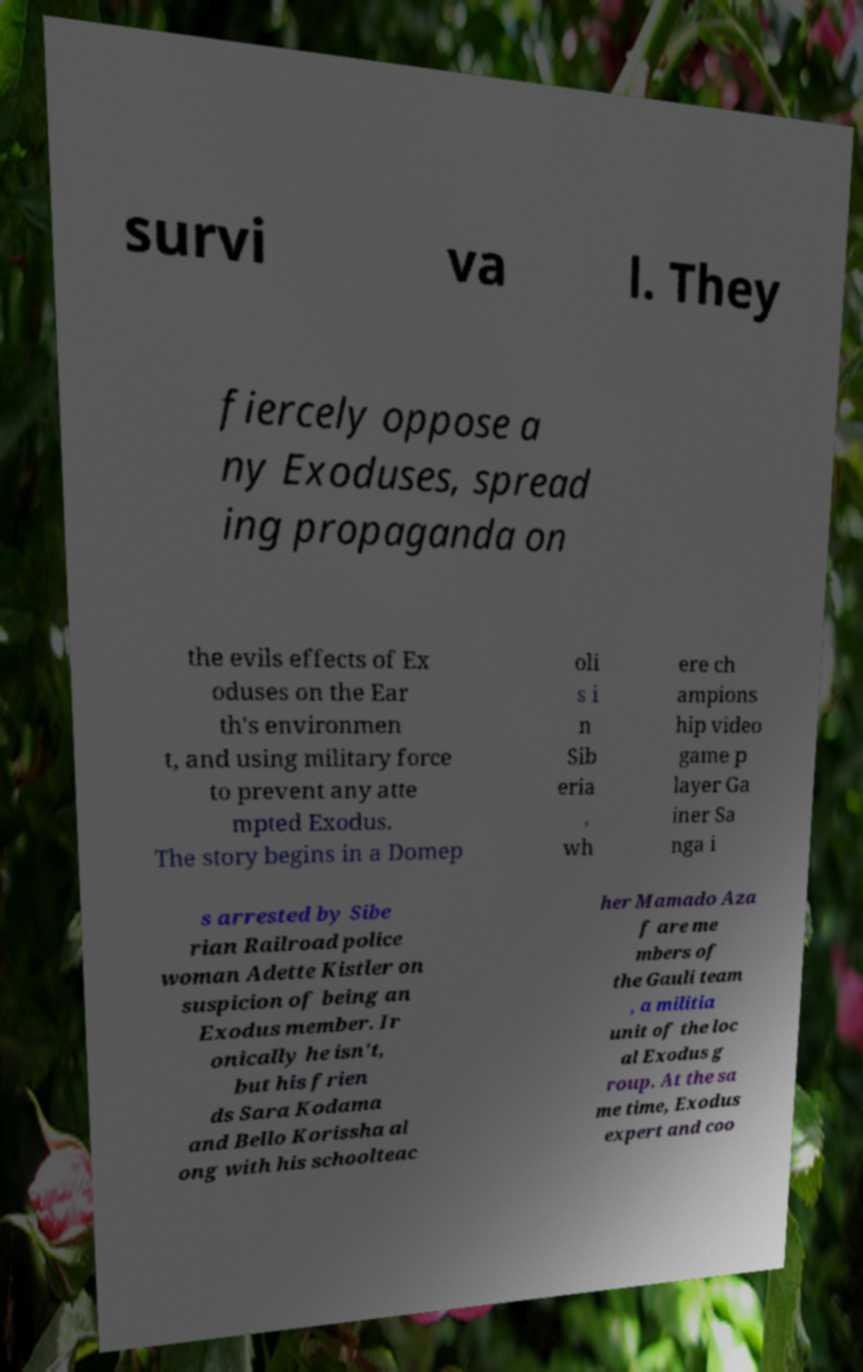I need the written content from this picture converted into text. Can you do that? survi va l. They fiercely oppose a ny Exoduses, spread ing propaganda on the evils effects of Ex oduses on the Ear th's environmen t, and using military force to prevent any atte mpted Exodus. The story begins in a Domep oli s i n Sib eria , wh ere ch ampions hip video game p layer Ga iner Sa nga i s arrested by Sibe rian Railroad police woman Adette Kistler on suspicion of being an Exodus member. Ir onically he isn't, but his frien ds Sara Kodama and Bello Korissha al ong with his schoolteac her Mamado Aza f are me mbers of the Gauli team , a militia unit of the loc al Exodus g roup. At the sa me time, Exodus expert and coo 